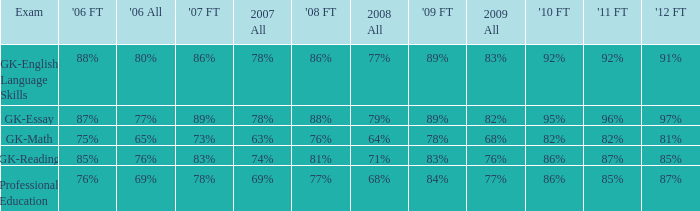What is the percentage for 2008 First time when in 2006 it was 85%? 81%. 